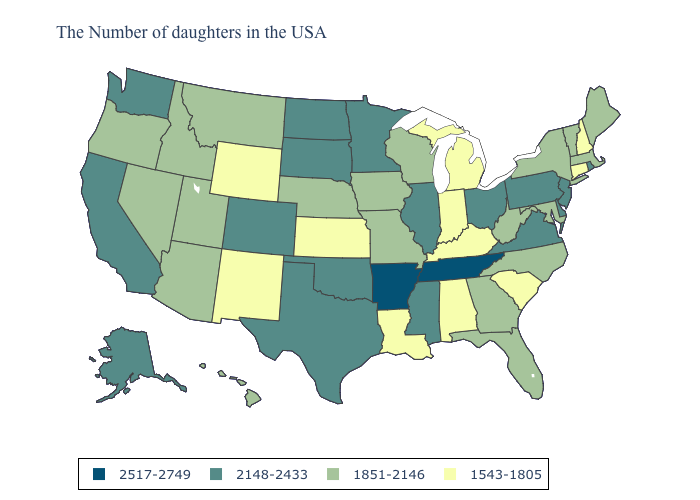What is the lowest value in the USA?
Give a very brief answer. 1543-1805. Does Wyoming have the lowest value in the West?
Keep it brief. Yes. What is the value of Utah?
Quick response, please. 1851-2146. What is the lowest value in the South?
Give a very brief answer. 1543-1805. Among the states that border Tennessee , which have the lowest value?
Concise answer only. Kentucky, Alabama. What is the value of New Mexico?
Answer briefly. 1543-1805. Name the states that have a value in the range 2148-2433?
Answer briefly. Rhode Island, New Jersey, Delaware, Pennsylvania, Virginia, Ohio, Illinois, Mississippi, Minnesota, Oklahoma, Texas, South Dakota, North Dakota, Colorado, California, Washington, Alaska. Does Arkansas have the highest value in the USA?
Concise answer only. Yes. Name the states that have a value in the range 1851-2146?
Write a very short answer. Maine, Massachusetts, Vermont, New York, Maryland, North Carolina, West Virginia, Florida, Georgia, Wisconsin, Missouri, Iowa, Nebraska, Utah, Montana, Arizona, Idaho, Nevada, Oregon, Hawaii. Name the states that have a value in the range 2148-2433?
Quick response, please. Rhode Island, New Jersey, Delaware, Pennsylvania, Virginia, Ohio, Illinois, Mississippi, Minnesota, Oklahoma, Texas, South Dakota, North Dakota, Colorado, California, Washington, Alaska. Name the states that have a value in the range 2517-2749?
Be succinct. Tennessee, Arkansas. What is the value of South Carolina?
Write a very short answer. 1543-1805. What is the highest value in states that border Vermont?
Give a very brief answer. 1851-2146. Does New York have the same value as Colorado?
Keep it brief. No. What is the value of Nebraska?
Be succinct. 1851-2146. 